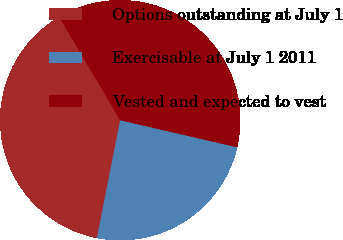Convert chart to OTSL. <chart><loc_0><loc_0><loc_500><loc_500><pie_chart><fcel>Options outstanding at July 1<fcel>Exercisable at July 1 2011<fcel>Vested and expected to vest<nl><fcel>38.4%<fcel>24.48%<fcel>37.11%<nl></chart> 